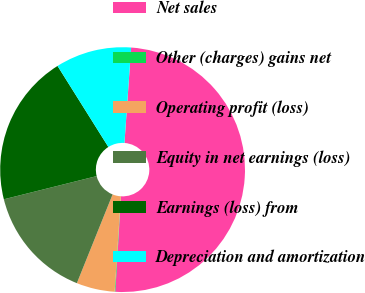Convert chart to OTSL. <chart><loc_0><loc_0><loc_500><loc_500><pie_chart><fcel>Net sales<fcel>Other (charges) gains net<fcel>Operating profit (loss)<fcel>Equity in net earnings (loss)<fcel>Earnings (loss) from<fcel>Depreciation and amortization<nl><fcel>49.84%<fcel>0.08%<fcel>5.06%<fcel>15.01%<fcel>19.98%<fcel>10.03%<nl></chart> 